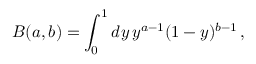Convert formula to latex. <formula><loc_0><loc_0><loc_500><loc_500>B ( a , b ) = \int _ { 0 } ^ { 1 } d y \, y ^ { a - 1 } ( 1 - y ) ^ { b - 1 } \, ,</formula> 